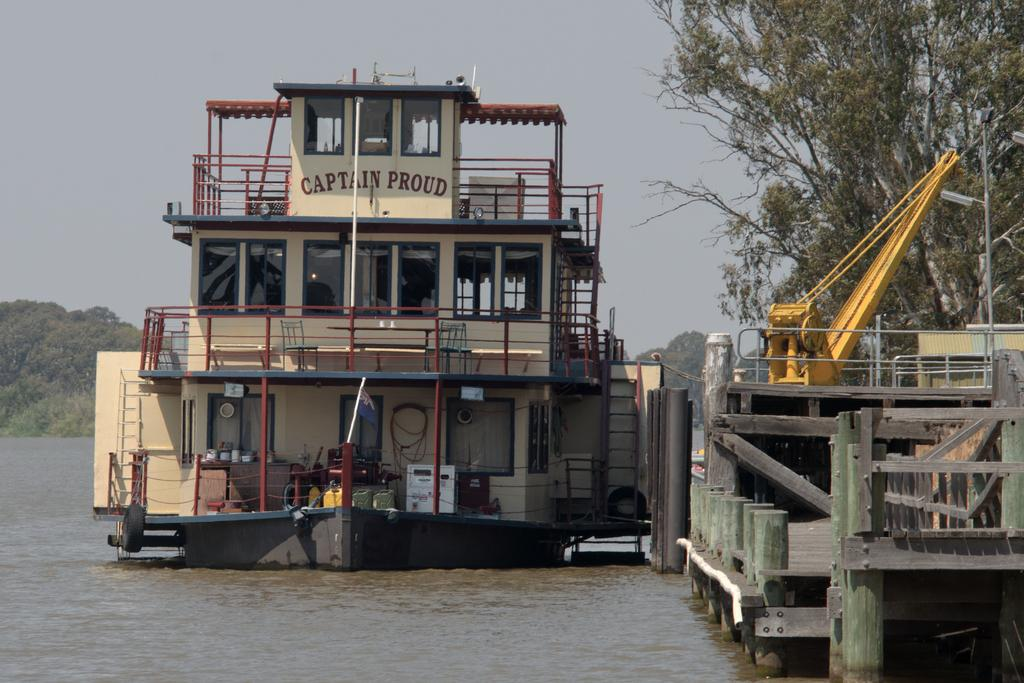What is the main subject of the image? The main subject of the image is a boat. Where is the boat located? The boat is on the water. What can be seen on the right side of the image? There are wooden poles and trees on the right side of the image. What features are present on the boat? Railings and rods are visible in the image. What is visible in the background of the image? The background of the image includes trees and the sky. What type of vest is the guide wearing in the image? There is no guide or vest present in the image; it features a boat on the water with wooden poles, trees, railings, and rods. 